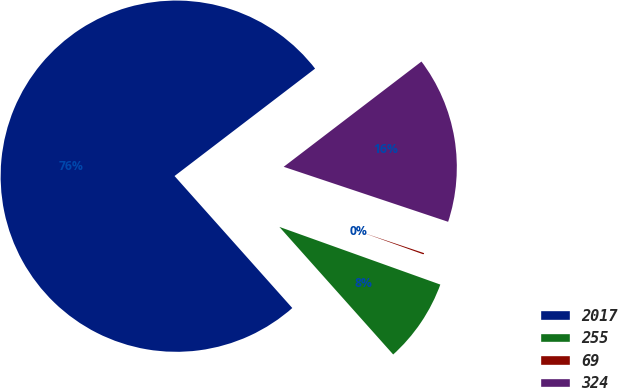Convert chart. <chart><loc_0><loc_0><loc_500><loc_500><pie_chart><fcel>2017<fcel>255<fcel>69<fcel>324<nl><fcel>76.21%<fcel>7.93%<fcel>0.34%<fcel>15.52%<nl></chart> 